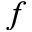Convert formula to latex. <formula><loc_0><loc_0><loc_500><loc_500>f</formula> 